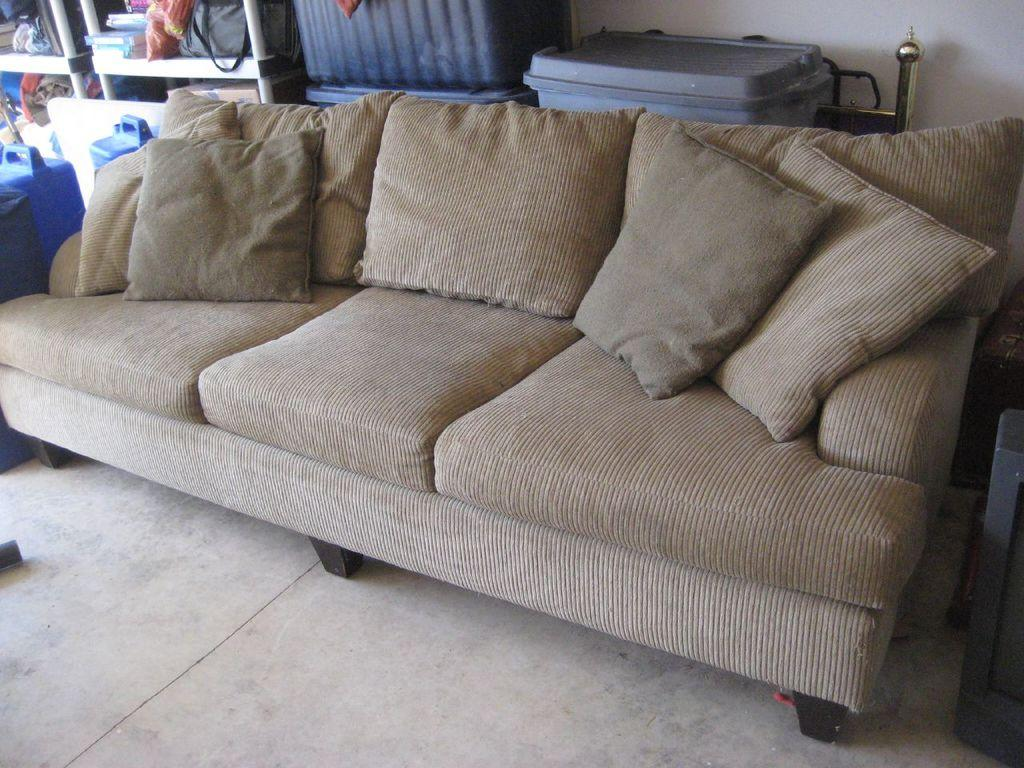What type of furniture is present in the image? There is a couch in the image. What can be seen on the couch? There are pillows on the couch. What object is visible in the image that can hold items? There is a container in the image. What items are related to personal care or fashion in the image? There are clothes in the image. What items are related to knowledge or education in the image? There are books in the image. Where is the bag located in the image? The bag is in a rack in the image. What type of architectural feature is present in the image? There is a wall in the image. What type of chess pieces can be seen on the couch in the image? There are no chess pieces present in the image. How many bikes are visible in the image? There are no bikes visible in the image. 